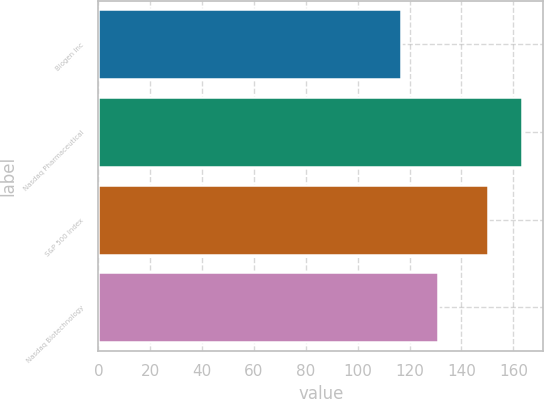<chart> <loc_0><loc_0><loc_500><loc_500><bar_chart><fcel>Biogen Inc<fcel>Nasdaq Pharmaceutical<fcel>S&P 500 Index<fcel>Nasdaq Biotechnology<nl><fcel>116.69<fcel>163.37<fcel>150.33<fcel>131<nl></chart> 